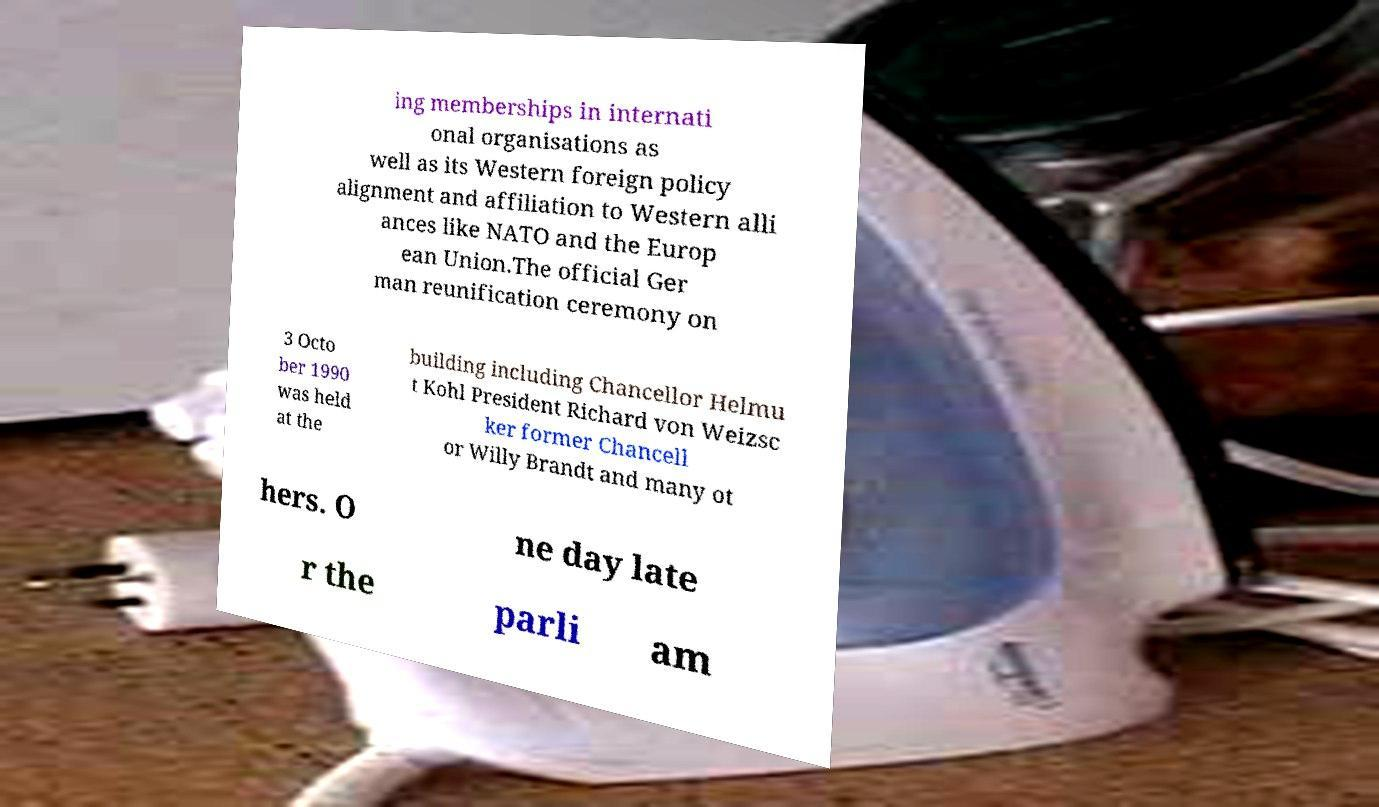I need the written content from this picture converted into text. Can you do that? ing memberships in internati onal organisations as well as its Western foreign policy alignment and affiliation to Western alli ances like NATO and the Europ ean Union.The official Ger man reunification ceremony on 3 Octo ber 1990 was held at the building including Chancellor Helmu t Kohl President Richard von Weizsc ker former Chancell or Willy Brandt and many ot hers. O ne day late r the parli am 